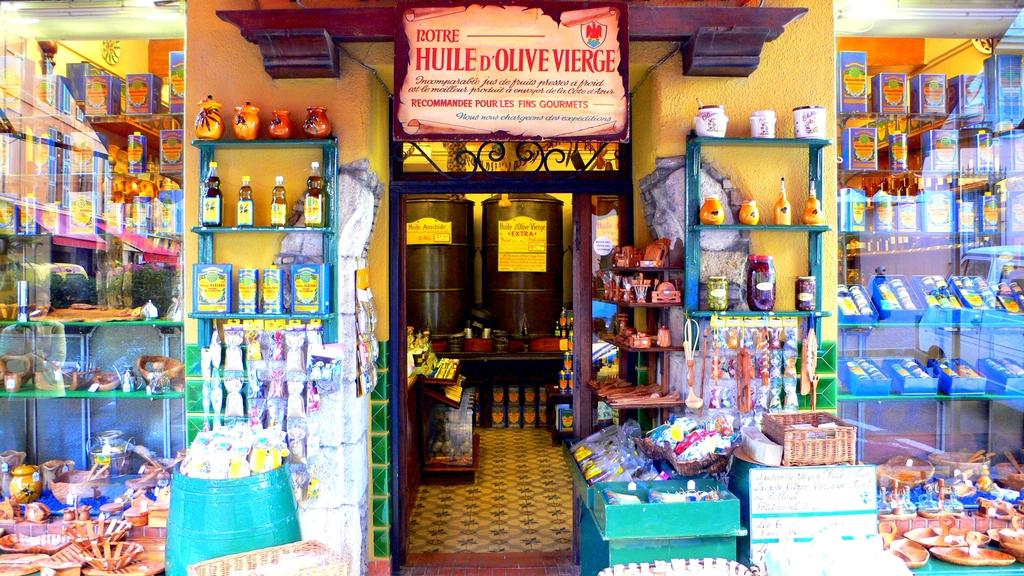<image>
Describe the image concisely. A crowded looking shop doorway with the word Rotre discernible on the top 